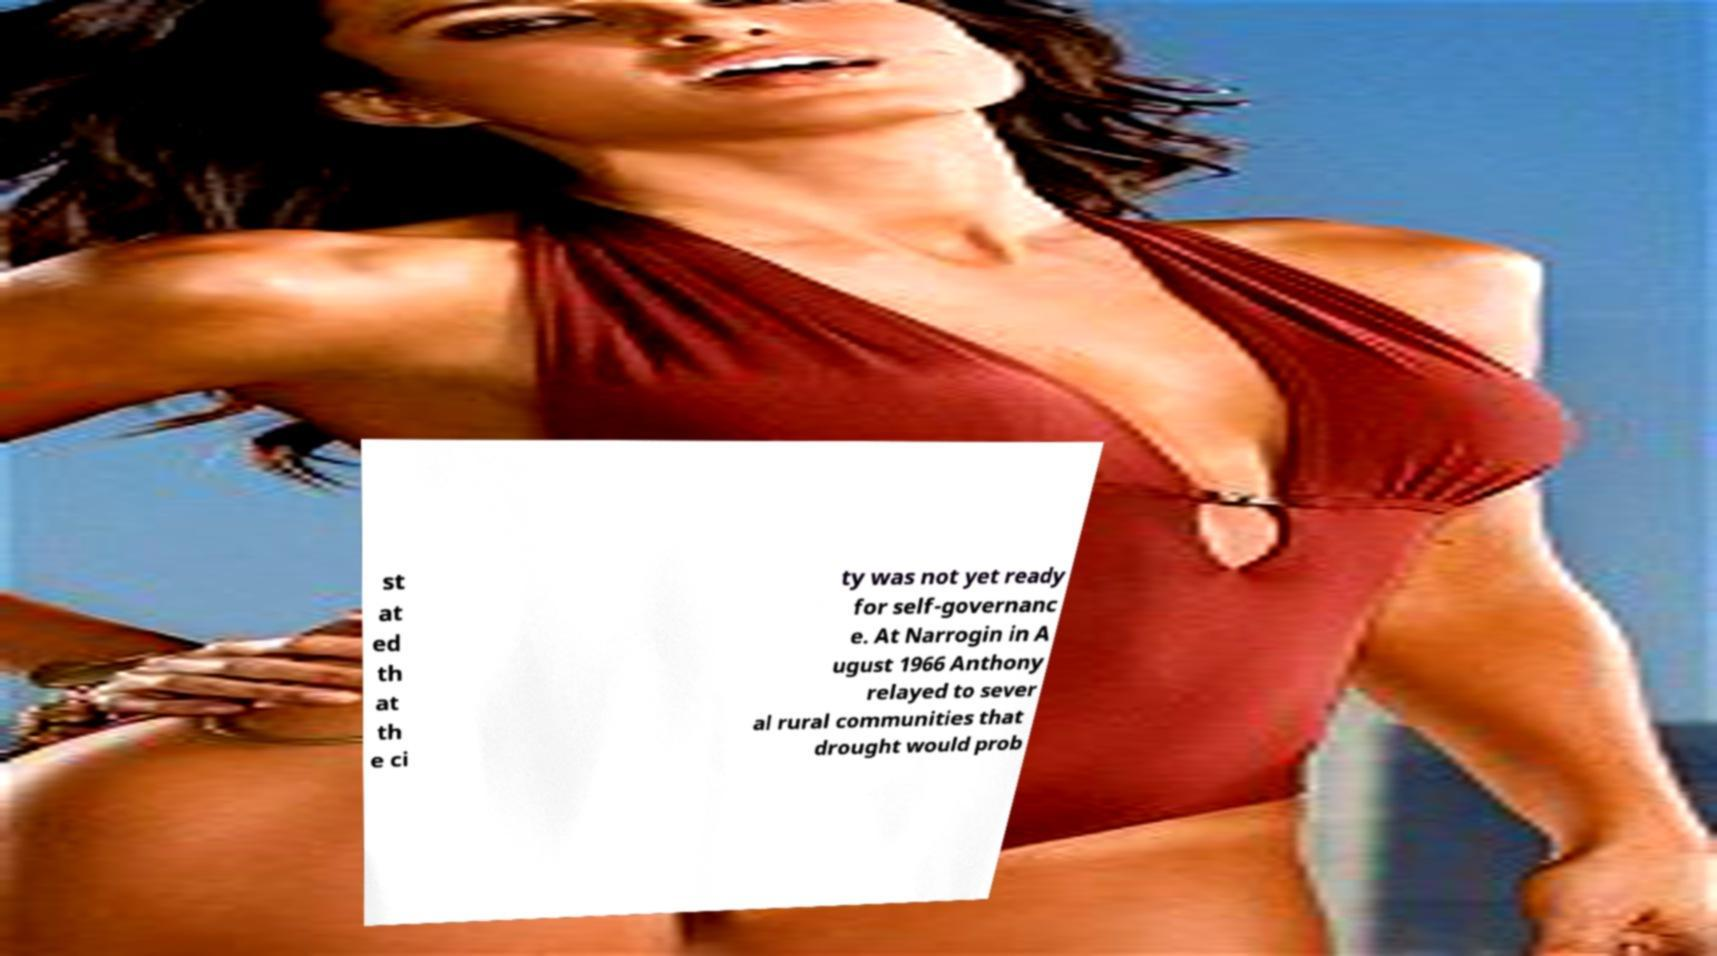Can you accurately transcribe the text from the provided image for me? st at ed th at th e ci ty was not yet ready for self-governanc e. At Narrogin in A ugust 1966 Anthony relayed to sever al rural communities that drought would prob 